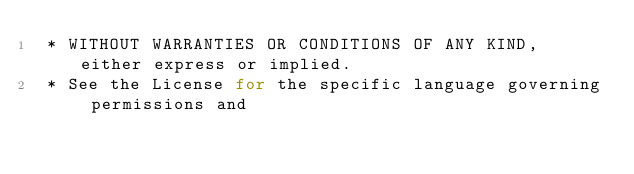Convert code to text. <code><loc_0><loc_0><loc_500><loc_500><_Java_> * WITHOUT WARRANTIES OR CONDITIONS OF ANY KIND, either express or implied.
 * See the License for the specific language governing permissions and</code> 